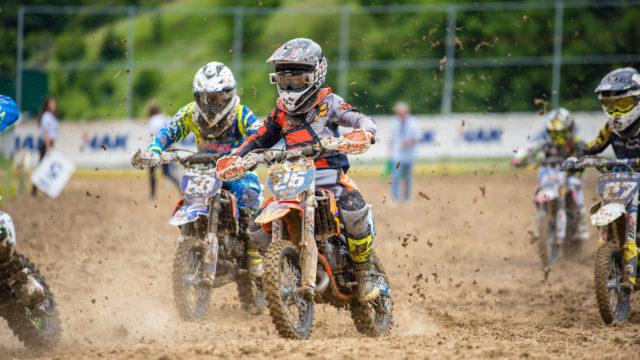What kind of event is likely being depicted in the photograph? The photo captures the intensity of a motocross race, evident from the riders' protective gear, the numbers displayed on the bikes, and the muddy terrain, which is characteristic of this competitive and thrilling off-road motorcycle racing sport. Which elements indicate that this is a competitive event rather than a casual ride? Several details suggest a competition: the riders' racing numbers, matching uniforms indicating team affiliation, concentration and positioning of the bikers suggesting a race for position, and the fenced off area with what appears to be spectators or officials in the background. 